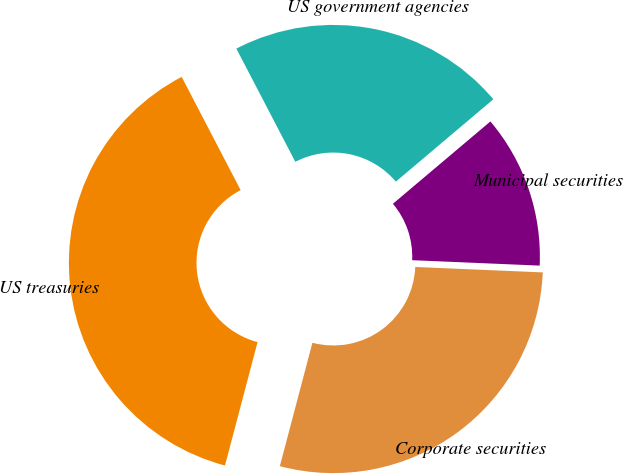<chart> <loc_0><loc_0><loc_500><loc_500><pie_chart><fcel>Corporate securities<fcel>US treasuries<fcel>US government agencies<fcel>Municipal securities<nl><fcel>28.43%<fcel>38.25%<fcel>21.48%<fcel>11.84%<nl></chart> 